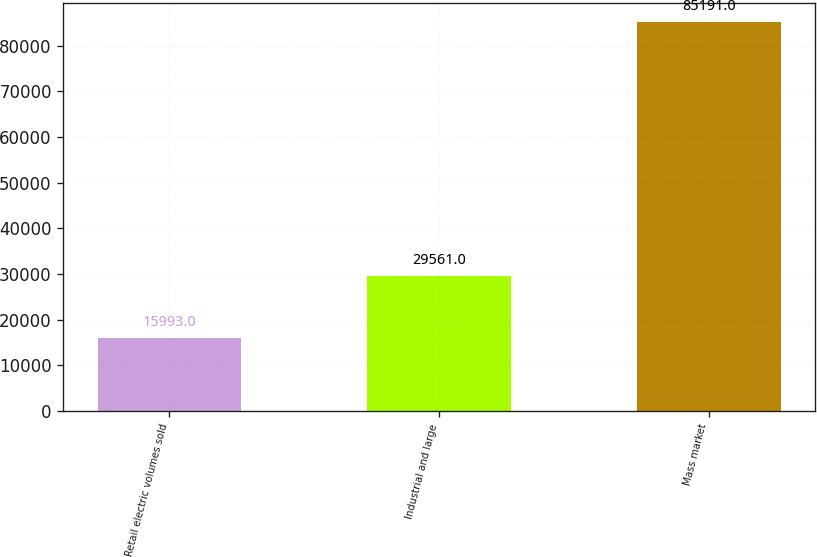Convert chart to OTSL. <chart><loc_0><loc_0><loc_500><loc_500><bar_chart><fcel>Retail electric volumes sold<fcel>Industrial and large<fcel>Mass market<nl><fcel>15993<fcel>29561<fcel>85191<nl></chart> 